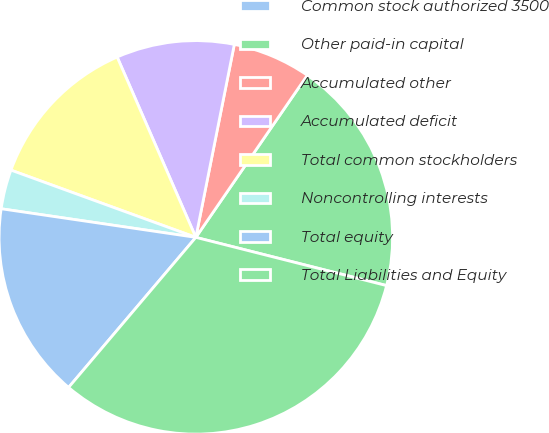<chart> <loc_0><loc_0><loc_500><loc_500><pie_chart><fcel>Common stock authorized 3500<fcel>Other paid-in capital<fcel>Accumulated other<fcel>Accumulated deficit<fcel>Total common stockholders<fcel>Noncontrolling interests<fcel>Total equity<fcel>Total Liabilities and Equity<nl><fcel>0.01%<fcel>19.35%<fcel>6.45%<fcel>9.68%<fcel>12.9%<fcel>3.23%<fcel>16.13%<fcel>32.25%<nl></chart> 